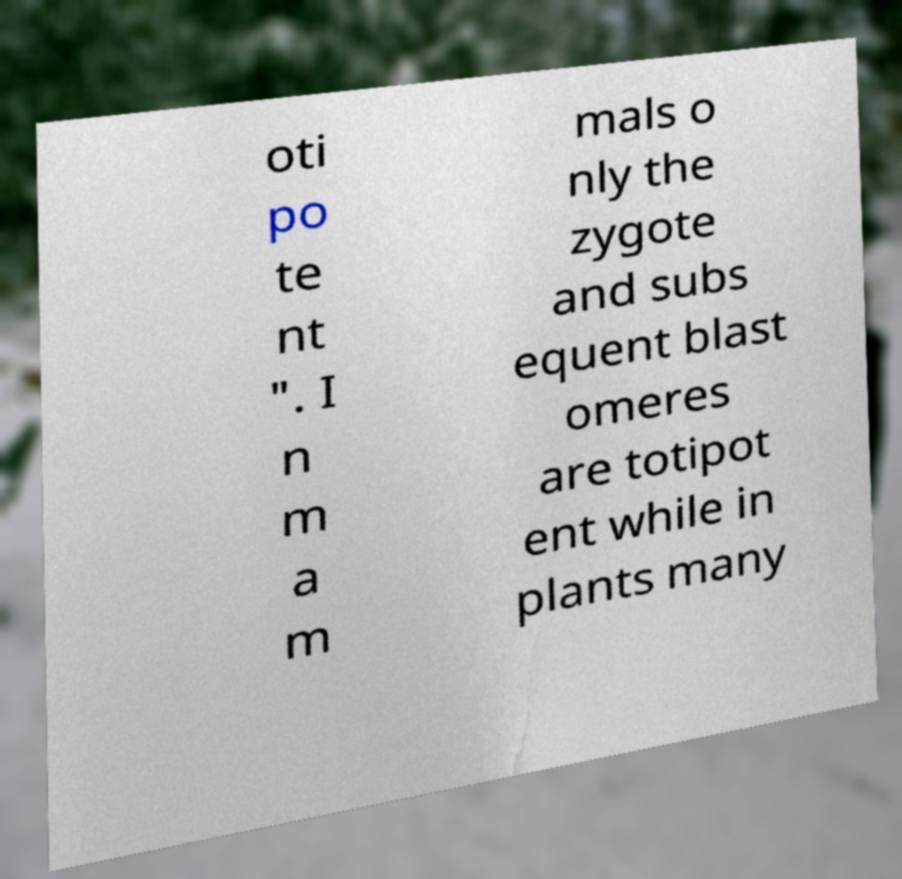What messages or text are displayed in this image? I need them in a readable, typed format. oti po te nt ". I n m a m mals o nly the zygote and subs equent blast omeres are totipot ent while in plants many 